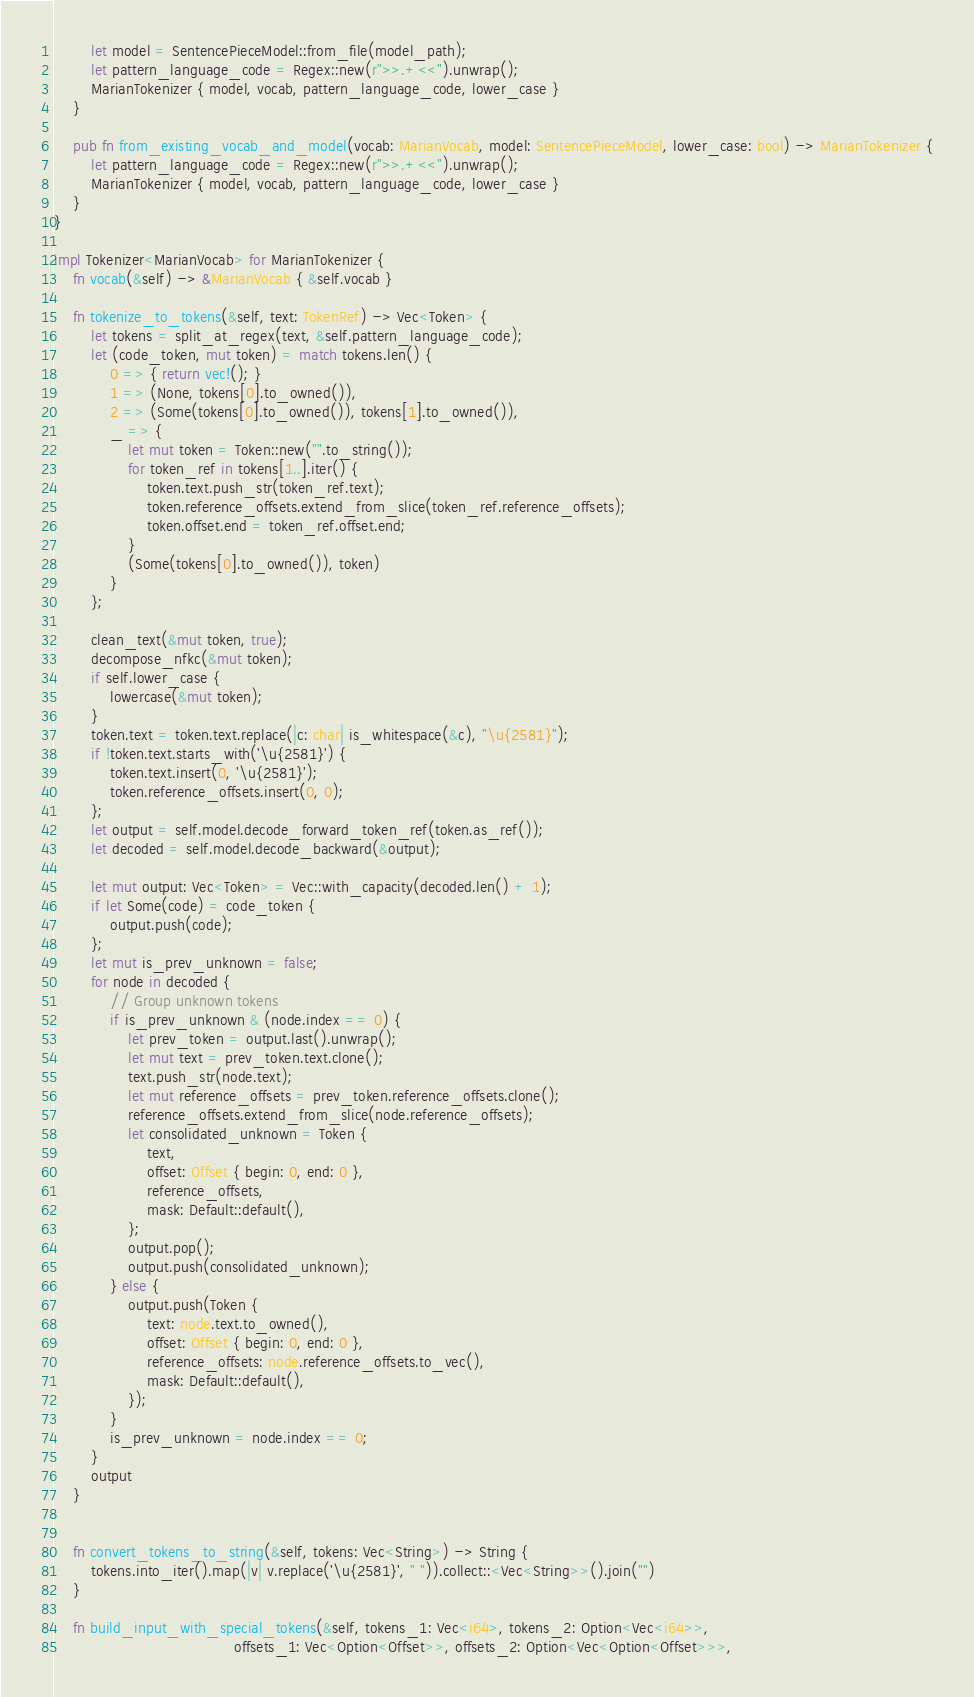<code> <loc_0><loc_0><loc_500><loc_500><_Rust_>        let model = SentencePieceModel::from_file(model_path);
        let pattern_language_code = Regex::new(r">>.+<<").unwrap();
        MarianTokenizer { model, vocab, pattern_language_code, lower_case }
    }

    pub fn from_existing_vocab_and_model(vocab: MarianVocab, model: SentencePieceModel, lower_case: bool) -> MarianTokenizer {
        let pattern_language_code = Regex::new(r">>.+<<").unwrap();
        MarianTokenizer { model, vocab, pattern_language_code, lower_case }
    }
}

impl Tokenizer<MarianVocab> for MarianTokenizer {
    fn vocab(&self) -> &MarianVocab { &self.vocab }

    fn tokenize_to_tokens(&self, text: TokenRef) -> Vec<Token> {
        let tokens = split_at_regex(text, &self.pattern_language_code);
        let (code_token, mut token) = match tokens.len() {
            0 => { return vec!(); }
            1 => (None, tokens[0].to_owned()),
            2 => (Some(tokens[0].to_owned()), tokens[1].to_owned()),
            _ => {
                let mut token = Token::new("".to_string());
                for token_ref in tokens[1..].iter() {
                    token.text.push_str(token_ref.text);
                    token.reference_offsets.extend_from_slice(token_ref.reference_offsets);
                    token.offset.end = token_ref.offset.end;
                }
                (Some(tokens[0].to_owned()), token)
            }
        };

        clean_text(&mut token, true);
        decompose_nfkc(&mut token);
        if self.lower_case {
            lowercase(&mut token);
        }
        token.text = token.text.replace(|c: char| is_whitespace(&c), "\u{2581}");
        if !token.text.starts_with('\u{2581}') {
            token.text.insert(0, '\u{2581}');
            token.reference_offsets.insert(0, 0);
        };
        let output = self.model.decode_forward_token_ref(token.as_ref());
        let decoded = self.model.decode_backward(&output);

        let mut output: Vec<Token> = Vec::with_capacity(decoded.len() + 1);
        if let Some(code) = code_token {
            output.push(code);
        };
        let mut is_prev_unknown = false;
        for node in decoded {
            // Group unknown tokens
            if is_prev_unknown & (node.index == 0) {
                let prev_token = output.last().unwrap();
                let mut text = prev_token.text.clone();
                text.push_str(node.text);
                let mut reference_offsets = prev_token.reference_offsets.clone();
                reference_offsets.extend_from_slice(node.reference_offsets);
                let consolidated_unknown = Token {
                    text,
                    offset: Offset { begin: 0, end: 0 },
                    reference_offsets,
                    mask: Default::default(),
                };
                output.pop();
                output.push(consolidated_unknown);
            } else {
                output.push(Token {
                    text: node.text.to_owned(),
                    offset: Offset { begin: 0, end: 0 },
                    reference_offsets: node.reference_offsets.to_vec(),
                    mask: Default::default(),
                });
            }
            is_prev_unknown = node.index == 0;
        }
        output
    }


    fn convert_tokens_to_string(&self, tokens: Vec<String>) -> String {
        tokens.into_iter().map(|v| v.replace('\u{2581}', " ")).collect::<Vec<String>>().join("")
    }

    fn build_input_with_special_tokens(&self, tokens_1: Vec<i64>, tokens_2: Option<Vec<i64>>,
                                       offsets_1: Vec<Option<Offset>>, offsets_2: Option<Vec<Option<Offset>>>,</code> 